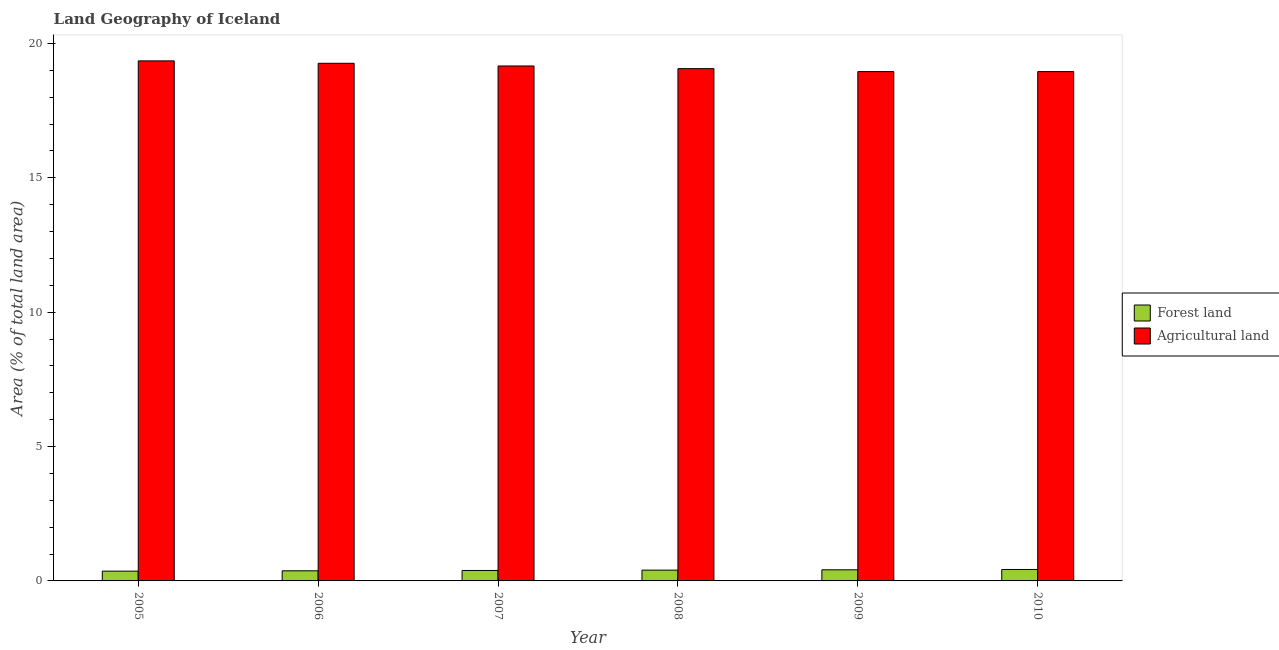How many different coloured bars are there?
Provide a short and direct response. 2. How many groups of bars are there?
Provide a succinct answer. 6. Are the number of bars per tick equal to the number of legend labels?
Ensure brevity in your answer.  Yes. Are the number of bars on each tick of the X-axis equal?
Give a very brief answer. Yes. How many bars are there on the 2nd tick from the left?
Make the answer very short. 2. How many bars are there on the 3rd tick from the right?
Give a very brief answer. 2. What is the percentage of land area under agriculture in 2008?
Ensure brevity in your answer.  19.06. Across all years, what is the maximum percentage of land area under agriculture?
Your answer should be very brief. 19.35. Across all years, what is the minimum percentage of land area under forests?
Keep it short and to the point. 0.36. What is the total percentage of land area under forests in the graph?
Make the answer very short. 2.37. What is the difference between the percentage of land area under agriculture in 2007 and that in 2009?
Provide a succinct answer. 0.21. What is the difference between the percentage of land area under forests in 2009 and the percentage of land area under agriculture in 2006?
Make the answer very short. 0.04. What is the average percentage of land area under agriculture per year?
Provide a succinct answer. 19.12. In the year 2008, what is the difference between the percentage of land area under forests and percentage of land area under agriculture?
Keep it short and to the point. 0. In how many years, is the percentage of land area under agriculture greater than 17 %?
Provide a succinct answer. 6. What is the ratio of the percentage of land area under forests in 2006 to that in 2010?
Keep it short and to the point. 0.88. Is the percentage of land area under forests in 2005 less than that in 2009?
Offer a very short reply. Yes. What is the difference between the highest and the second highest percentage of land area under agriculture?
Offer a very short reply. 0.09. What is the difference between the highest and the lowest percentage of land area under agriculture?
Your answer should be compact. 0.4. In how many years, is the percentage of land area under agriculture greater than the average percentage of land area under agriculture taken over all years?
Your answer should be compact. 3. What does the 2nd bar from the left in 2008 represents?
Provide a short and direct response. Agricultural land. What does the 2nd bar from the right in 2006 represents?
Provide a short and direct response. Forest land. How many years are there in the graph?
Make the answer very short. 6. Does the graph contain grids?
Provide a succinct answer. No. Where does the legend appear in the graph?
Your response must be concise. Center right. What is the title of the graph?
Your answer should be very brief. Land Geography of Iceland. Does "By country of asylum" appear as one of the legend labels in the graph?
Your answer should be very brief. No. What is the label or title of the Y-axis?
Make the answer very short. Area (% of total land area). What is the Area (% of total land area) in Forest land in 2005?
Ensure brevity in your answer.  0.36. What is the Area (% of total land area) of Agricultural land in 2005?
Offer a very short reply. 19.35. What is the Area (% of total land area) in Forest land in 2006?
Offer a terse response. 0.38. What is the Area (% of total land area) in Agricultural land in 2006?
Provide a short and direct response. 19.26. What is the Area (% of total land area) in Forest land in 2007?
Provide a succinct answer. 0.39. What is the Area (% of total land area) of Agricultural land in 2007?
Your answer should be compact. 19.16. What is the Area (% of total land area) of Forest land in 2008?
Your response must be concise. 0.4. What is the Area (% of total land area) of Agricultural land in 2008?
Make the answer very short. 19.06. What is the Area (% of total land area) of Forest land in 2009?
Your answer should be compact. 0.41. What is the Area (% of total land area) in Agricultural land in 2009?
Make the answer very short. 18.95. What is the Area (% of total land area) in Forest land in 2010?
Keep it short and to the point. 0.43. What is the Area (% of total land area) in Agricultural land in 2010?
Keep it short and to the point. 18.95. Across all years, what is the maximum Area (% of total land area) of Forest land?
Provide a short and direct response. 0.43. Across all years, what is the maximum Area (% of total land area) in Agricultural land?
Make the answer very short. 19.35. Across all years, what is the minimum Area (% of total land area) in Forest land?
Your answer should be very brief. 0.36. Across all years, what is the minimum Area (% of total land area) of Agricultural land?
Your answer should be very brief. 18.95. What is the total Area (% of total land area) of Forest land in the graph?
Provide a succinct answer. 2.37. What is the total Area (% of total land area) of Agricultural land in the graph?
Offer a very short reply. 114.74. What is the difference between the Area (% of total land area) in Forest land in 2005 and that in 2006?
Your answer should be compact. -0.01. What is the difference between the Area (% of total land area) of Agricultural land in 2005 and that in 2006?
Provide a short and direct response. 0.09. What is the difference between the Area (% of total land area) of Forest land in 2005 and that in 2007?
Your answer should be compact. -0.02. What is the difference between the Area (% of total land area) in Agricultural land in 2005 and that in 2007?
Offer a very short reply. 0.19. What is the difference between the Area (% of total land area) in Forest land in 2005 and that in 2008?
Your answer should be very brief. -0.04. What is the difference between the Area (% of total land area) of Agricultural land in 2005 and that in 2008?
Provide a short and direct response. 0.29. What is the difference between the Area (% of total land area) of Forest land in 2005 and that in 2009?
Your answer should be very brief. -0.05. What is the difference between the Area (% of total land area) of Agricultural land in 2005 and that in 2009?
Your response must be concise. 0.4. What is the difference between the Area (% of total land area) in Forest land in 2005 and that in 2010?
Your answer should be compact. -0.06. What is the difference between the Area (% of total land area) in Agricultural land in 2005 and that in 2010?
Your answer should be very brief. 0.4. What is the difference between the Area (% of total land area) of Forest land in 2006 and that in 2007?
Offer a terse response. -0.01. What is the difference between the Area (% of total land area) in Agricultural land in 2006 and that in 2007?
Give a very brief answer. 0.1. What is the difference between the Area (% of total land area) of Forest land in 2006 and that in 2008?
Your response must be concise. -0.02. What is the difference between the Area (% of total land area) of Agricultural land in 2006 and that in 2008?
Ensure brevity in your answer.  0.2. What is the difference between the Area (% of total land area) of Forest land in 2006 and that in 2009?
Your response must be concise. -0.04. What is the difference between the Area (% of total land area) of Agricultural land in 2006 and that in 2009?
Offer a very short reply. 0.31. What is the difference between the Area (% of total land area) of Forest land in 2006 and that in 2010?
Your answer should be very brief. -0.05. What is the difference between the Area (% of total land area) of Agricultural land in 2006 and that in 2010?
Provide a short and direct response. 0.31. What is the difference between the Area (% of total land area) of Forest land in 2007 and that in 2008?
Offer a terse response. -0.01. What is the difference between the Area (% of total land area) in Agricultural land in 2007 and that in 2008?
Offer a very short reply. 0.1. What is the difference between the Area (% of total land area) in Forest land in 2007 and that in 2009?
Provide a succinct answer. -0.02. What is the difference between the Area (% of total land area) of Agricultural land in 2007 and that in 2009?
Your response must be concise. 0.21. What is the difference between the Area (% of total land area) of Forest land in 2007 and that in 2010?
Your answer should be compact. -0.04. What is the difference between the Area (% of total land area) of Agricultural land in 2007 and that in 2010?
Offer a very short reply. 0.21. What is the difference between the Area (% of total land area) in Forest land in 2008 and that in 2009?
Ensure brevity in your answer.  -0.01. What is the difference between the Area (% of total land area) in Agricultural land in 2008 and that in 2009?
Offer a terse response. 0.11. What is the difference between the Area (% of total land area) of Forest land in 2008 and that in 2010?
Your response must be concise. -0.02. What is the difference between the Area (% of total land area) of Agricultural land in 2008 and that in 2010?
Provide a short and direct response. 0.11. What is the difference between the Area (% of total land area) in Forest land in 2009 and that in 2010?
Your answer should be compact. -0.01. What is the difference between the Area (% of total land area) in Forest land in 2005 and the Area (% of total land area) in Agricultural land in 2006?
Your response must be concise. -18.9. What is the difference between the Area (% of total land area) of Forest land in 2005 and the Area (% of total land area) of Agricultural land in 2007?
Your answer should be very brief. -18.8. What is the difference between the Area (% of total land area) in Forest land in 2005 and the Area (% of total land area) in Agricultural land in 2008?
Offer a very short reply. -18.7. What is the difference between the Area (% of total land area) in Forest land in 2005 and the Area (% of total land area) in Agricultural land in 2009?
Give a very brief answer. -18.59. What is the difference between the Area (% of total land area) of Forest land in 2005 and the Area (% of total land area) of Agricultural land in 2010?
Keep it short and to the point. -18.59. What is the difference between the Area (% of total land area) of Forest land in 2006 and the Area (% of total land area) of Agricultural land in 2007?
Offer a terse response. -18.79. What is the difference between the Area (% of total land area) in Forest land in 2006 and the Area (% of total land area) in Agricultural land in 2008?
Provide a succinct answer. -18.69. What is the difference between the Area (% of total land area) in Forest land in 2006 and the Area (% of total land area) in Agricultural land in 2009?
Your answer should be very brief. -18.58. What is the difference between the Area (% of total land area) of Forest land in 2006 and the Area (% of total land area) of Agricultural land in 2010?
Ensure brevity in your answer.  -18.58. What is the difference between the Area (% of total land area) of Forest land in 2007 and the Area (% of total land area) of Agricultural land in 2008?
Provide a short and direct response. -18.67. What is the difference between the Area (% of total land area) in Forest land in 2007 and the Area (% of total land area) in Agricultural land in 2009?
Provide a short and direct response. -18.56. What is the difference between the Area (% of total land area) in Forest land in 2007 and the Area (% of total land area) in Agricultural land in 2010?
Your answer should be very brief. -18.56. What is the difference between the Area (% of total land area) in Forest land in 2008 and the Area (% of total land area) in Agricultural land in 2009?
Your answer should be compact. -18.55. What is the difference between the Area (% of total land area) in Forest land in 2008 and the Area (% of total land area) in Agricultural land in 2010?
Offer a terse response. -18.55. What is the difference between the Area (% of total land area) of Forest land in 2009 and the Area (% of total land area) of Agricultural land in 2010?
Ensure brevity in your answer.  -18.54. What is the average Area (% of total land area) in Forest land per year?
Your answer should be compact. 0.4. What is the average Area (% of total land area) of Agricultural land per year?
Offer a terse response. 19.12. In the year 2005, what is the difference between the Area (% of total land area) in Forest land and Area (% of total land area) in Agricultural land?
Keep it short and to the point. -18.99. In the year 2006, what is the difference between the Area (% of total land area) of Forest land and Area (% of total land area) of Agricultural land?
Offer a terse response. -18.89. In the year 2007, what is the difference between the Area (% of total land area) of Forest land and Area (% of total land area) of Agricultural land?
Give a very brief answer. -18.77. In the year 2008, what is the difference between the Area (% of total land area) of Forest land and Area (% of total land area) of Agricultural land?
Your answer should be compact. -18.66. In the year 2009, what is the difference between the Area (% of total land area) of Forest land and Area (% of total land area) of Agricultural land?
Your response must be concise. -18.54. In the year 2010, what is the difference between the Area (% of total land area) of Forest land and Area (% of total land area) of Agricultural land?
Your answer should be very brief. -18.53. What is the ratio of the Area (% of total land area) in Forest land in 2005 to that in 2006?
Keep it short and to the point. 0.97. What is the ratio of the Area (% of total land area) in Forest land in 2005 to that in 2007?
Keep it short and to the point. 0.94. What is the ratio of the Area (% of total land area) of Agricultural land in 2005 to that in 2007?
Offer a very short reply. 1.01. What is the ratio of the Area (% of total land area) in Forest land in 2005 to that in 2008?
Your answer should be very brief. 0.91. What is the ratio of the Area (% of total land area) of Agricultural land in 2005 to that in 2008?
Keep it short and to the point. 1.02. What is the ratio of the Area (% of total land area) in Forest land in 2005 to that in 2009?
Ensure brevity in your answer.  0.88. What is the ratio of the Area (% of total land area) of Agricultural land in 2005 to that in 2009?
Make the answer very short. 1.02. What is the ratio of the Area (% of total land area) in Forest land in 2005 to that in 2010?
Provide a succinct answer. 0.85. What is the ratio of the Area (% of total land area) of Agricultural land in 2005 to that in 2010?
Keep it short and to the point. 1.02. What is the ratio of the Area (% of total land area) of Forest land in 2006 to that in 2007?
Offer a very short reply. 0.97. What is the ratio of the Area (% of total land area) in Agricultural land in 2006 to that in 2007?
Provide a short and direct response. 1.01. What is the ratio of the Area (% of total land area) in Forest land in 2006 to that in 2008?
Keep it short and to the point. 0.94. What is the ratio of the Area (% of total land area) in Agricultural land in 2006 to that in 2008?
Give a very brief answer. 1.01. What is the ratio of the Area (% of total land area) in Forest land in 2006 to that in 2009?
Keep it short and to the point. 0.91. What is the ratio of the Area (% of total land area) of Agricultural land in 2006 to that in 2009?
Keep it short and to the point. 1.02. What is the ratio of the Area (% of total land area) in Forest land in 2006 to that in 2010?
Offer a very short reply. 0.88. What is the ratio of the Area (% of total land area) of Agricultural land in 2006 to that in 2010?
Make the answer very short. 1.02. What is the ratio of the Area (% of total land area) of Forest land in 2007 to that in 2008?
Provide a succinct answer. 0.97. What is the ratio of the Area (% of total land area) of Forest land in 2007 to that in 2009?
Keep it short and to the point. 0.94. What is the ratio of the Area (% of total land area) in Agricultural land in 2007 to that in 2009?
Offer a very short reply. 1.01. What is the ratio of the Area (% of total land area) of Forest land in 2007 to that in 2010?
Offer a very short reply. 0.91. What is the ratio of the Area (% of total land area) in Agricultural land in 2007 to that in 2010?
Your answer should be very brief. 1.01. What is the ratio of the Area (% of total land area) of Forest land in 2008 to that in 2009?
Make the answer very short. 0.97. What is the ratio of the Area (% of total land area) of Forest land in 2008 to that in 2010?
Offer a very short reply. 0.94. What is the ratio of the Area (% of total land area) of Agricultural land in 2008 to that in 2010?
Make the answer very short. 1.01. What is the ratio of the Area (% of total land area) in Forest land in 2009 to that in 2010?
Your answer should be very brief. 0.97. What is the ratio of the Area (% of total land area) in Agricultural land in 2009 to that in 2010?
Your answer should be compact. 1. What is the difference between the highest and the second highest Area (% of total land area) in Forest land?
Provide a succinct answer. 0.01. What is the difference between the highest and the second highest Area (% of total land area) of Agricultural land?
Give a very brief answer. 0.09. What is the difference between the highest and the lowest Area (% of total land area) of Forest land?
Keep it short and to the point. 0.06. What is the difference between the highest and the lowest Area (% of total land area) of Agricultural land?
Make the answer very short. 0.4. 